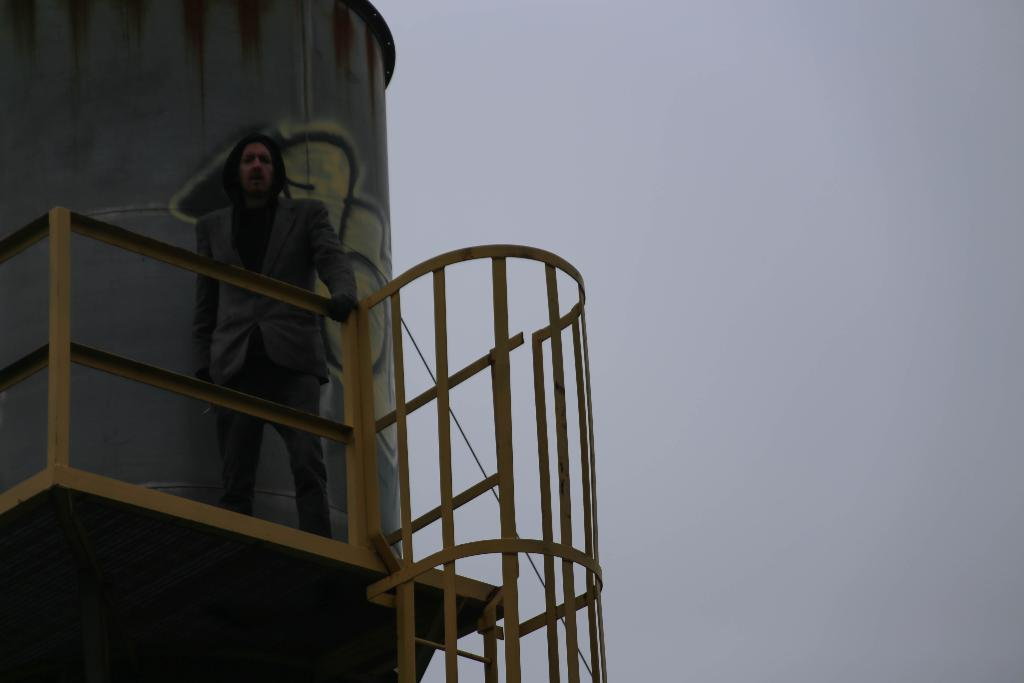What can be seen on the right side of the image? The sky is visible on the right side of the image. What is located on the left side of the image? There is a cylinder-shaped object on the left side of the image. Who is near the cylinder-shaped object? A person is standing near the cylinder-shaped object. What is present near the person? There are railings near the person. What type of glove is the judge wearing in the image? There is no glove or judge present in the image. Who is the partner of the person standing near the cylinder-shaped object? There is no information about a partner for the person in the image. 